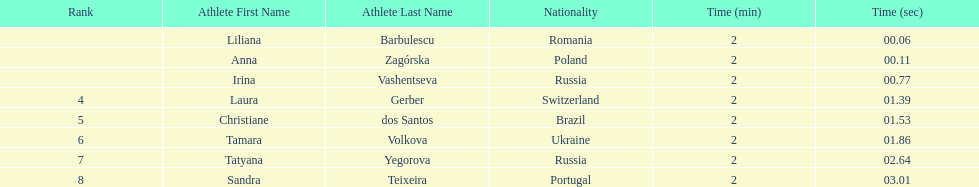Which south american country placed after irina vashentseva? Brazil. 